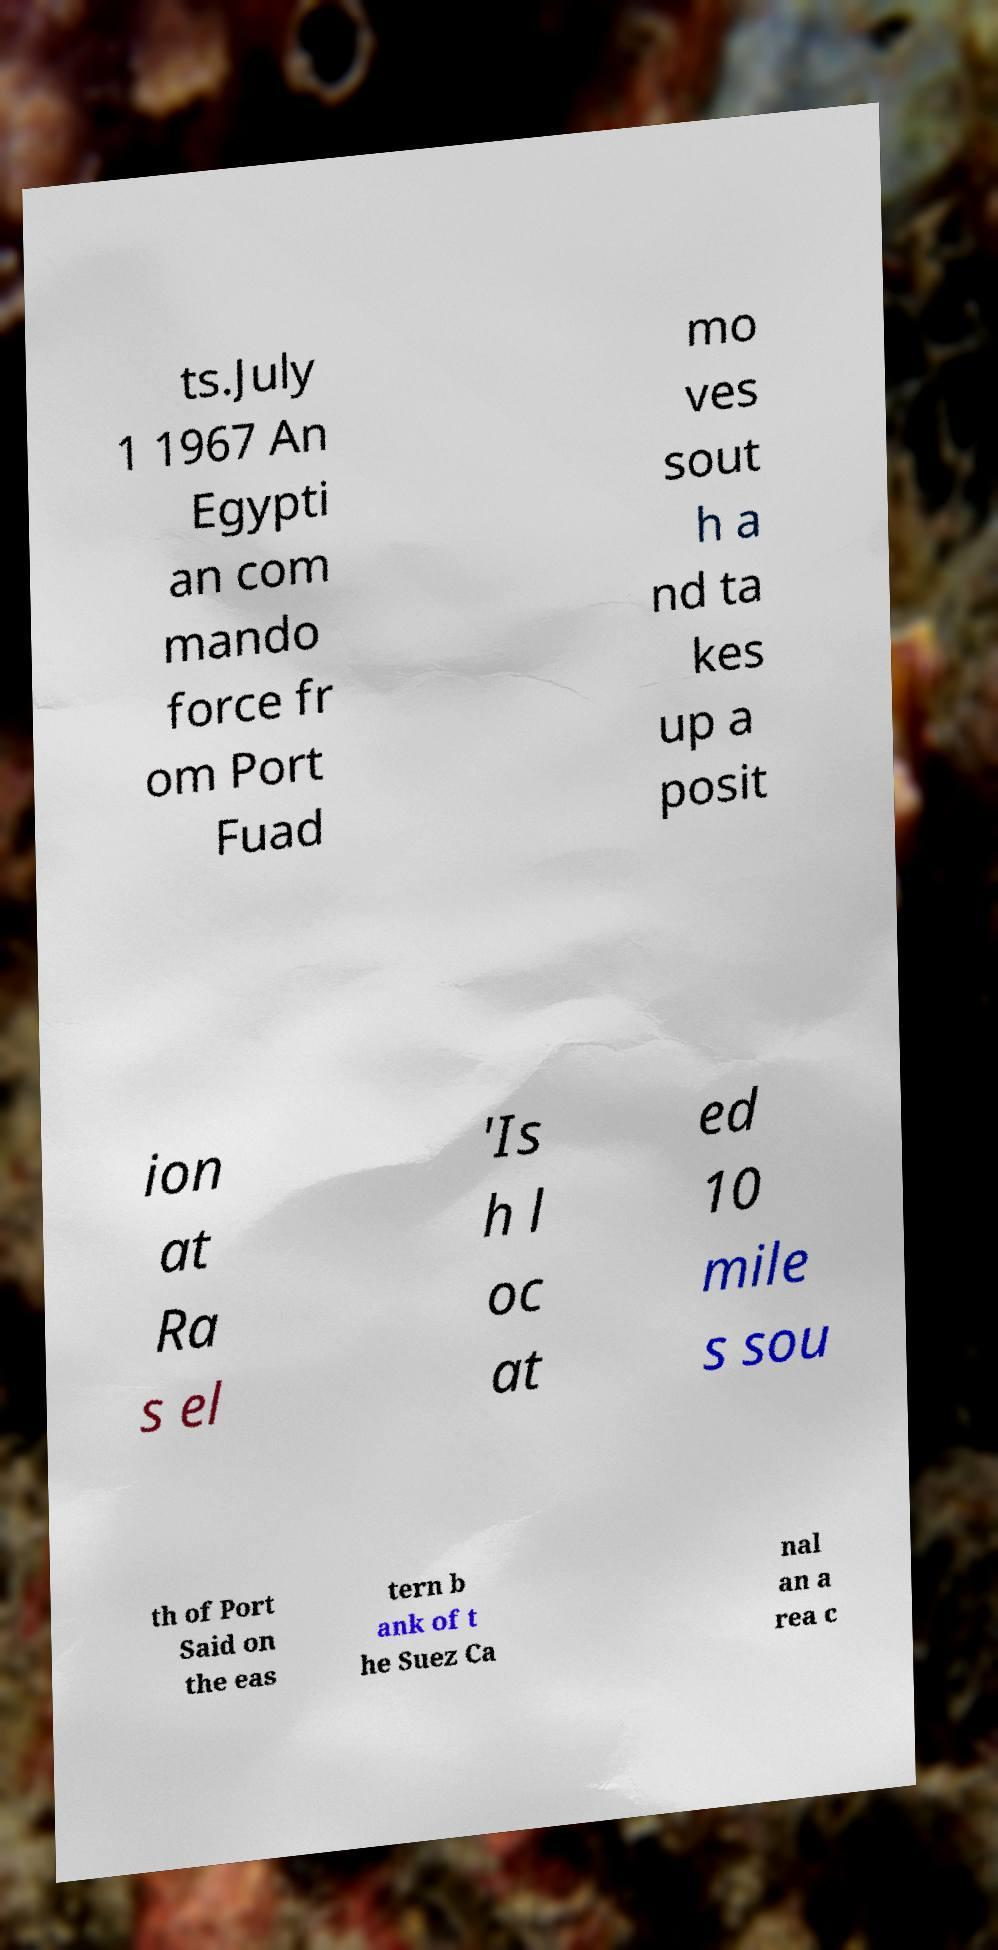Please identify and transcribe the text found in this image. ts.July 1 1967 An Egypti an com mando force fr om Port Fuad mo ves sout h a nd ta kes up a posit ion at Ra s el 'Is h l oc at ed 10 mile s sou th of Port Said on the eas tern b ank of t he Suez Ca nal an a rea c 